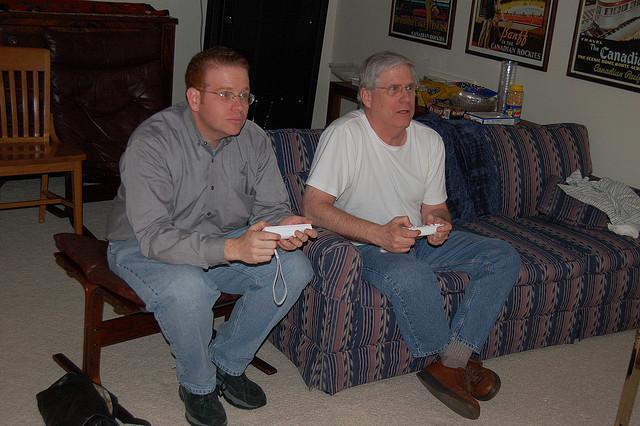How many fingers is the man on the left holding up?
Give a very brief answer. 0. How many cowboy hats?
Give a very brief answer. 0. How many people are playing?
Give a very brief answer. 2. How many men are in this image?
Give a very brief answer. 2. How many are wearing glasses?
Give a very brief answer. 2. How many bean bag chairs are in this photo?
Give a very brief answer. 0. How many people?
Give a very brief answer. 2. How many people are visible?
Give a very brief answer. 2. 